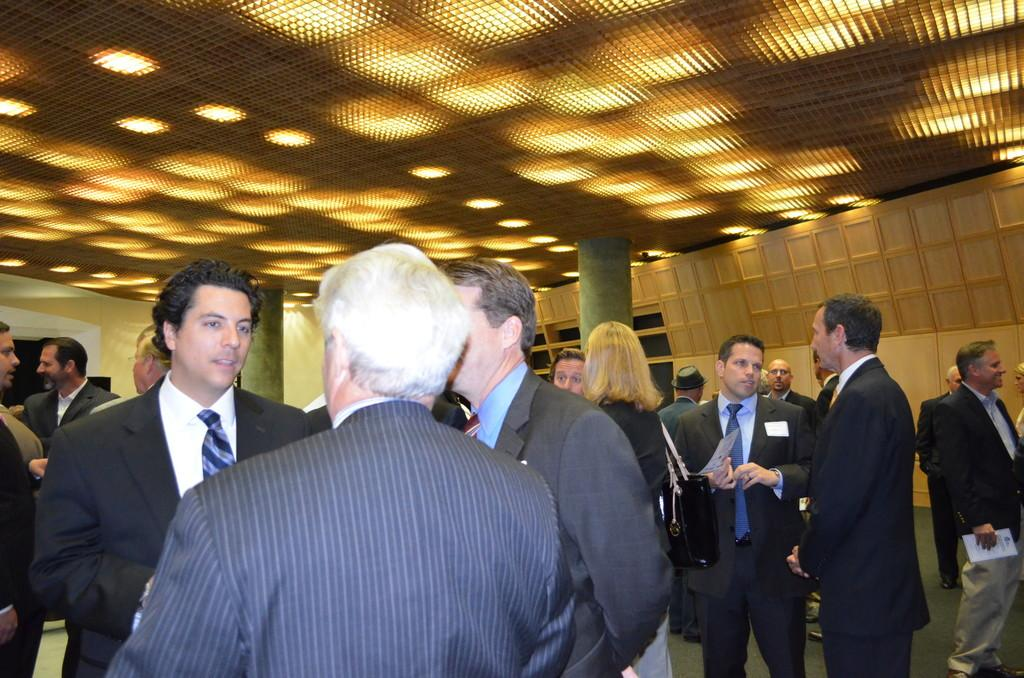What is happening in the image? There are people standing in the image. Can you describe what one person is holding or carrying? One person is carrying a bag. What architectural features can be seen in the background of the image? There are pillars and walls in the background of the image. What is visible at the top of the image? Lights are visible at the top of the image. How many houses can be seen in the image? There are no houses visible in the image. What type of team is present in the image? There is no team present in the image; it features people standing and carrying a bag. 